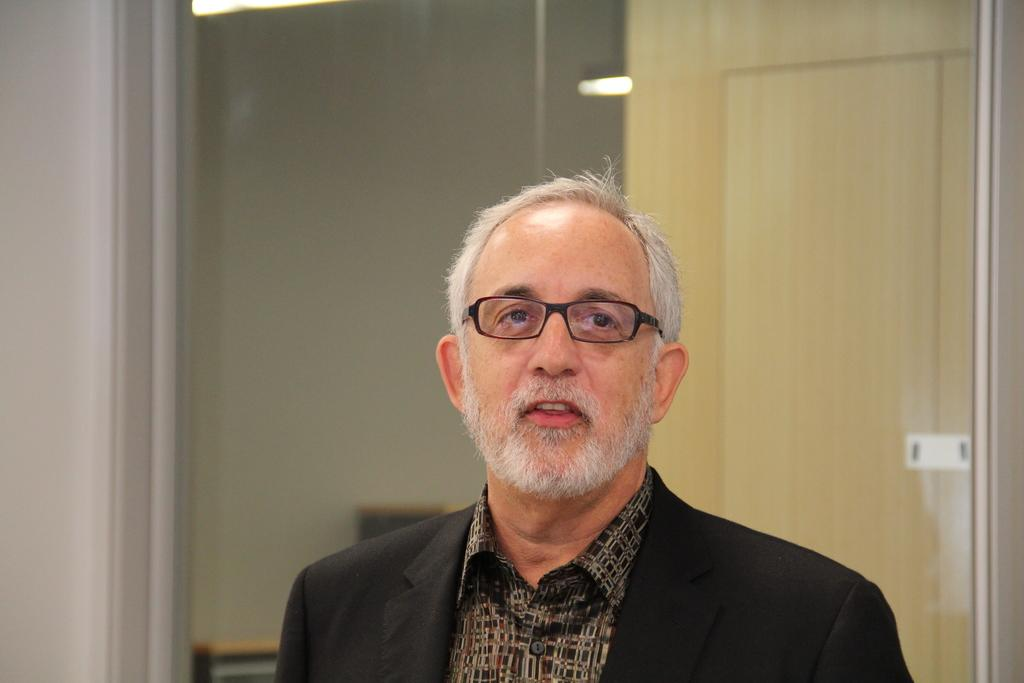Who or what is the main subject in the center of the image? There is a person in the center of the image. What is located behind the person? There is a door behind the person. Can you describe any illumination in the image? There are lights visible in the image. What can be seen in the background of the image? There is a wall in the background of the image. What type of calculator is being used by the person in the image? There is no calculator present in the image. What role does the porter play in the image? There is no porter present in the image. 